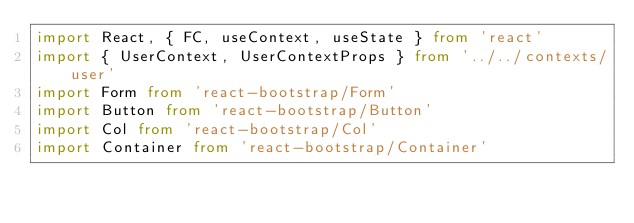<code> <loc_0><loc_0><loc_500><loc_500><_TypeScript_>import React, { FC, useContext, useState } from 'react'
import { UserContext, UserContextProps } from '../../contexts/user'
import Form from 'react-bootstrap/Form'
import Button from 'react-bootstrap/Button'
import Col from 'react-bootstrap/Col'
import Container from 'react-bootstrap/Container'</code> 